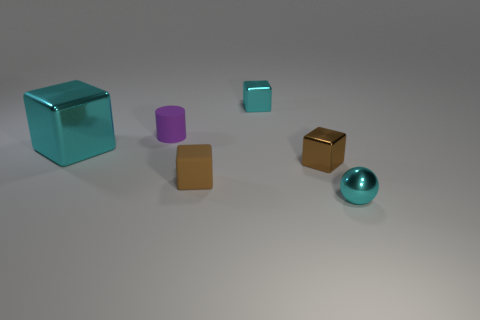How many cyan blocks must be subtracted to get 1 cyan blocks? 1 Subtract 1 cubes. How many cubes are left? 3 Add 4 tiny brown shiny cubes. How many objects exist? 10 Subtract all balls. How many objects are left? 5 Add 5 tiny cyan spheres. How many tiny cyan spheres are left? 6 Add 3 big red shiny cylinders. How many big red shiny cylinders exist? 3 Subtract 0 purple blocks. How many objects are left? 6 Subtract all small cyan shiny objects. Subtract all brown shiny blocks. How many objects are left? 3 